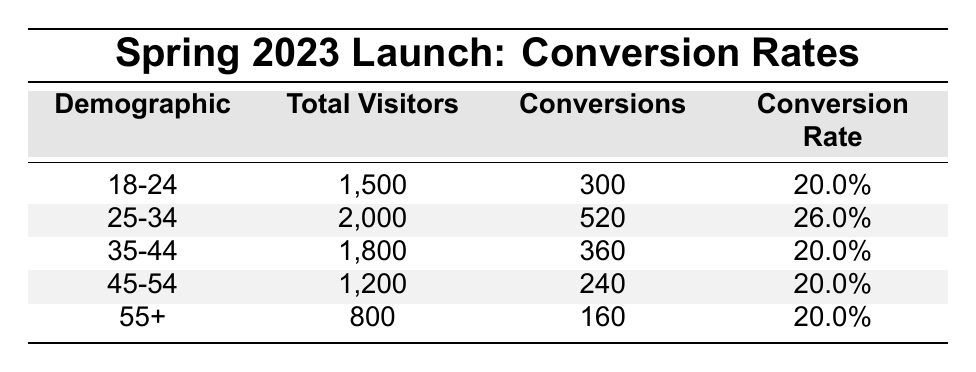What is the conversion rate for the demographic aged 25-34? To find the conversion rate for the 25-34 demographic, refer directly to the table where this demographic is listed. The conversion rate is stated as 26.0%.
Answer: 26.0% How many total visitors were there in the demographic aged 45-54? Look at the row corresponding to the 45-54 demographic in the table. The total visitors listed under that demographic are 1,200.
Answer: 1,200 Is the conversion rate for the 18-24 demographic higher than that of the 35-44 demographic? Check the conversion rates for both demographics in the table. The 18-24 demographic has a conversion rate of 20.0%, and the 35-44 demographic also has a conversion rate of 20.0%. Since they are equal, the answer is no.
Answer: No What is the total number of conversions for all demographics? To find the total number of conversions, sum the conversions for each demographic: 300 + 520 + 360 + 240 + 160 = 1,580.
Answer: 1,580 What is the average conversion rate across all demographics? To calculate the average conversion rate, combine all individual conversion rates and divide by the number of demographics: (20.0 + 26.0 + 20.0 + 20.0 + 20.0) / 5 = 21.2%.
Answer: 21.2% Which demographic has the highest number of conversions? Examine the 'Conversions' column in the table to find the highest value. The 25-34 demographic has the highest number of conversions at 520.
Answer: 25-34 Is the total number of visitors for the 55+ demographic less than the total for the 18-24 demographic? Compare the total visitors for both demographics. The 55+ demographic has 800 visitors, while the 18-24 demographic has 1,500. Since 800 is less than 1,500, the answer is yes.
Answer: Yes If the demographic aged 35-44 had 200 more conversions, what would their new conversion rate be? First, add 200 to the current conversions for the 35-44 demographic, which would be 360 + 200 = 560 conversions. The total visitors remain 1,800. Thus, the new conversion rate would be (560/1800) * 100 = 31.1%.
Answer: 31.1% How many conversions were made by the demographic aged 55+? Look at the conversions listed for the 55+ demographic in the table, which is stated as 160.
Answer: 160 